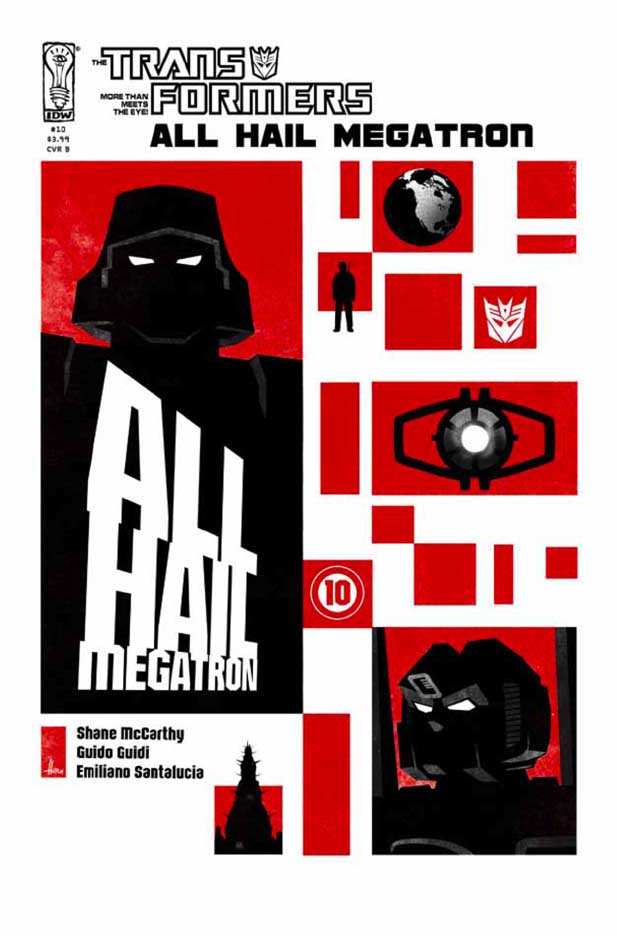Describe what a film poster based on this comic cover might look like. A film poster based on this comic cover would likely magnify the dramatic elements and dark tones. Megatron's silhouette would be more detailed, perhaps showing him in a powerful pose with a menacing expression. The red and black color scheme would remain, but with more texture and depth to create a more lifelike, cinematic feel. Key characters might appear in the background or in action poses, providing more context to the story. The title, 'ALL HAIL MEGATRON,' would be bold and metallic, with a tagline hinting at rebellion or an impending battle. The overall design would aim to evoke a sense of urgency and epic scale, drawing the viewer into the high-stakes conflict. 